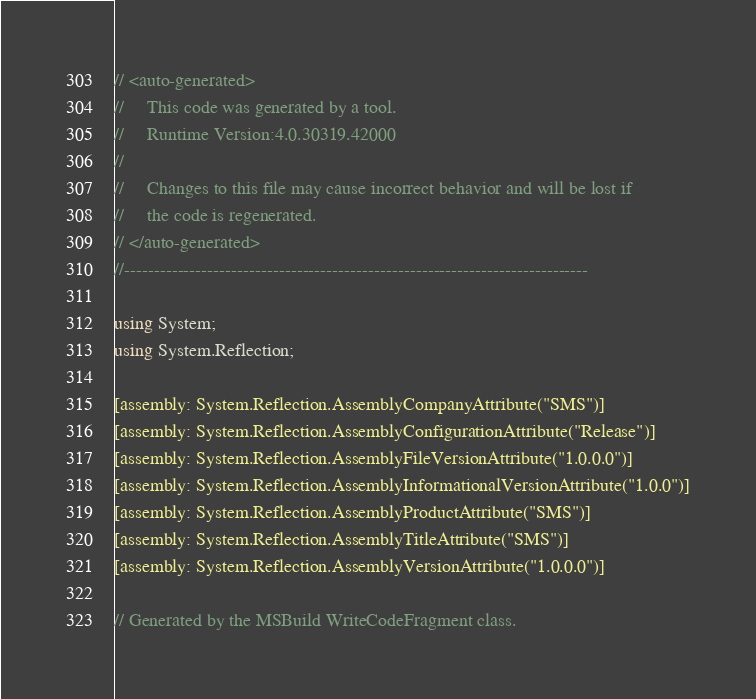Convert code to text. <code><loc_0><loc_0><loc_500><loc_500><_C#_>// <auto-generated>
//     This code was generated by a tool.
//     Runtime Version:4.0.30319.42000
//
//     Changes to this file may cause incorrect behavior and will be lost if
//     the code is regenerated.
// </auto-generated>
//------------------------------------------------------------------------------

using System;
using System.Reflection;

[assembly: System.Reflection.AssemblyCompanyAttribute("SMS")]
[assembly: System.Reflection.AssemblyConfigurationAttribute("Release")]
[assembly: System.Reflection.AssemblyFileVersionAttribute("1.0.0.0")]
[assembly: System.Reflection.AssemblyInformationalVersionAttribute("1.0.0")]
[assembly: System.Reflection.AssemblyProductAttribute("SMS")]
[assembly: System.Reflection.AssemblyTitleAttribute("SMS")]
[assembly: System.Reflection.AssemblyVersionAttribute("1.0.0.0")]

// Generated by the MSBuild WriteCodeFragment class.

</code> 